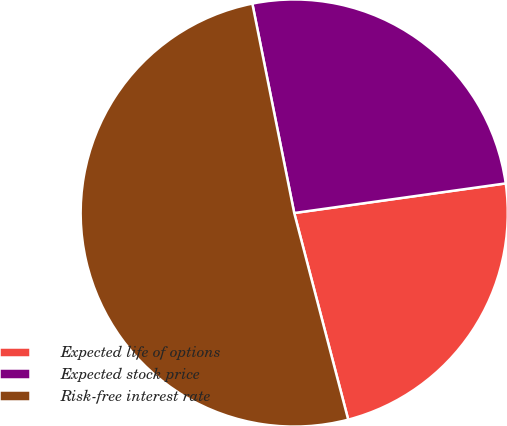<chart> <loc_0><loc_0><loc_500><loc_500><pie_chart><fcel>Expected life of options<fcel>Expected stock price<fcel>Risk-free interest rate<nl><fcel>23.15%<fcel>25.93%<fcel>50.93%<nl></chart> 